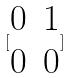Convert formula to latex. <formula><loc_0><loc_0><loc_500><loc_500>[ \begin{matrix} 0 & 1 \\ 0 & 0 \end{matrix} ]</formula> 